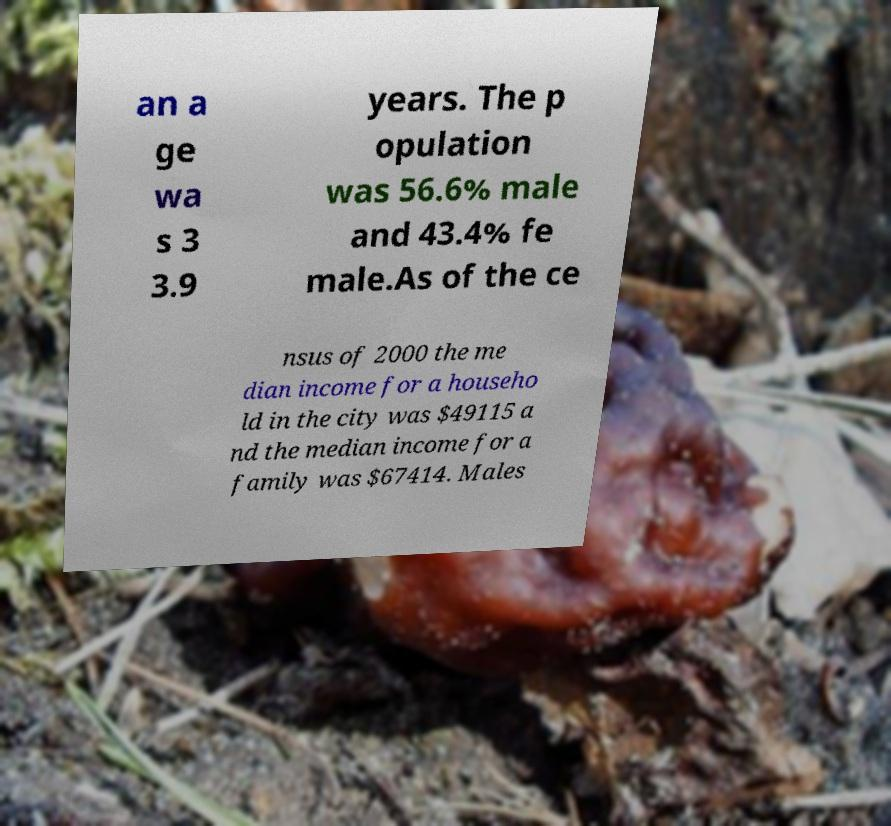Please identify and transcribe the text found in this image. an a ge wa s 3 3.9 years. The p opulation was 56.6% male and 43.4% fe male.As of the ce nsus of 2000 the me dian income for a househo ld in the city was $49115 a nd the median income for a family was $67414. Males 